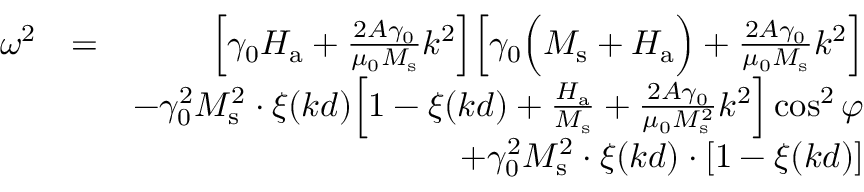Convert formula to latex. <formula><loc_0><loc_0><loc_500><loc_500>\begin{array} { r l r } { \omega ^ { 2 } } & { = } & { \left [ \gamma _ { 0 } H _ { a } + \frac { 2 A \gamma _ { 0 } } { \mu _ { 0 } M _ { s } } k ^ { 2 } \right ] \left [ \gamma _ { 0 } \left ( M _ { s } + H _ { a } \right ) + \frac { 2 A \gamma _ { 0 } } { \mu _ { 0 } M _ { s } } k ^ { 2 } \right ] } \\ & { - \gamma _ { 0 } ^ { 2 } M _ { s } ^ { 2 } \cdot \xi ( k d ) \left [ 1 - \xi ( k d ) + \frac { H _ { a } } { M _ { s } } + \frac { 2 A \gamma _ { 0 } } { \mu _ { 0 } M _ { s } ^ { 2 } } k ^ { 2 } \right ] \cos ^ { 2 } { \varphi } } \\ & { + \gamma _ { 0 } ^ { 2 } M _ { s } ^ { 2 } \cdot \xi ( k d ) \cdot [ 1 - \xi ( k d ) ] } \end{array}</formula> 